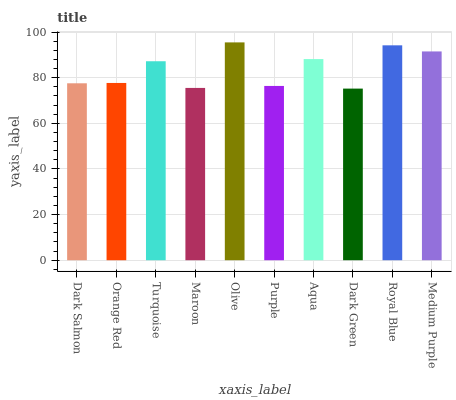Is Dark Green the minimum?
Answer yes or no. Yes. Is Olive the maximum?
Answer yes or no. Yes. Is Orange Red the minimum?
Answer yes or no. No. Is Orange Red the maximum?
Answer yes or no. No. Is Orange Red greater than Dark Salmon?
Answer yes or no. Yes. Is Dark Salmon less than Orange Red?
Answer yes or no. Yes. Is Dark Salmon greater than Orange Red?
Answer yes or no. No. Is Orange Red less than Dark Salmon?
Answer yes or no. No. Is Turquoise the high median?
Answer yes or no. Yes. Is Orange Red the low median?
Answer yes or no. Yes. Is Maroon the high median?
Answer yes or no. No. Is Olive the low median?
Answer yes or no. No. 